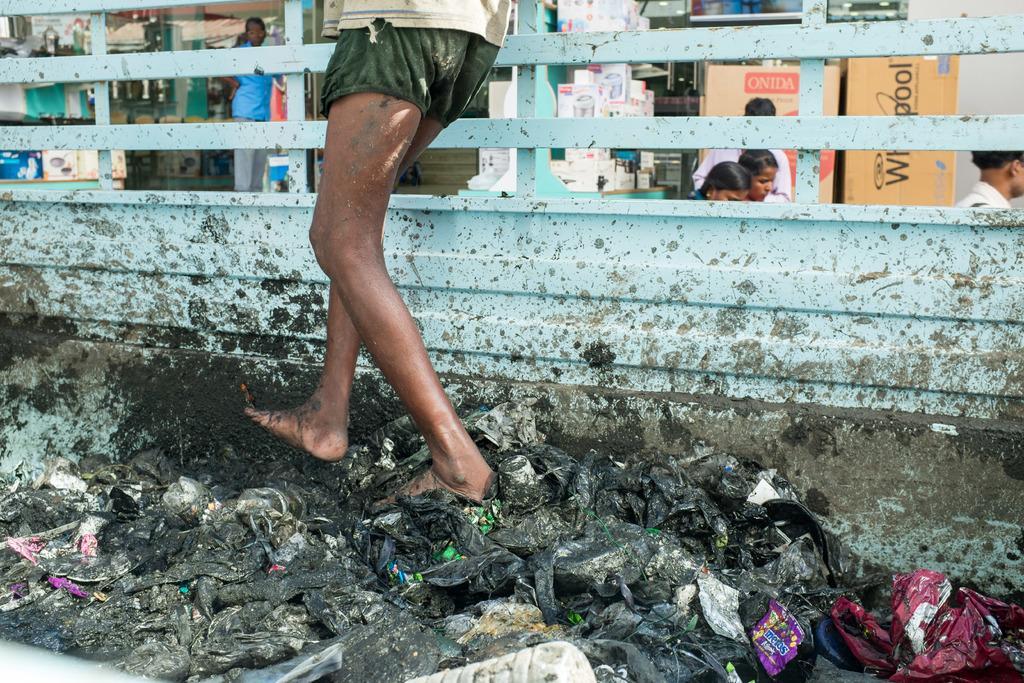How would you summarize this image in a sentence or two? In this picture we can see a man is standing on the vehicle, in the background we can find few more people and some other things. 